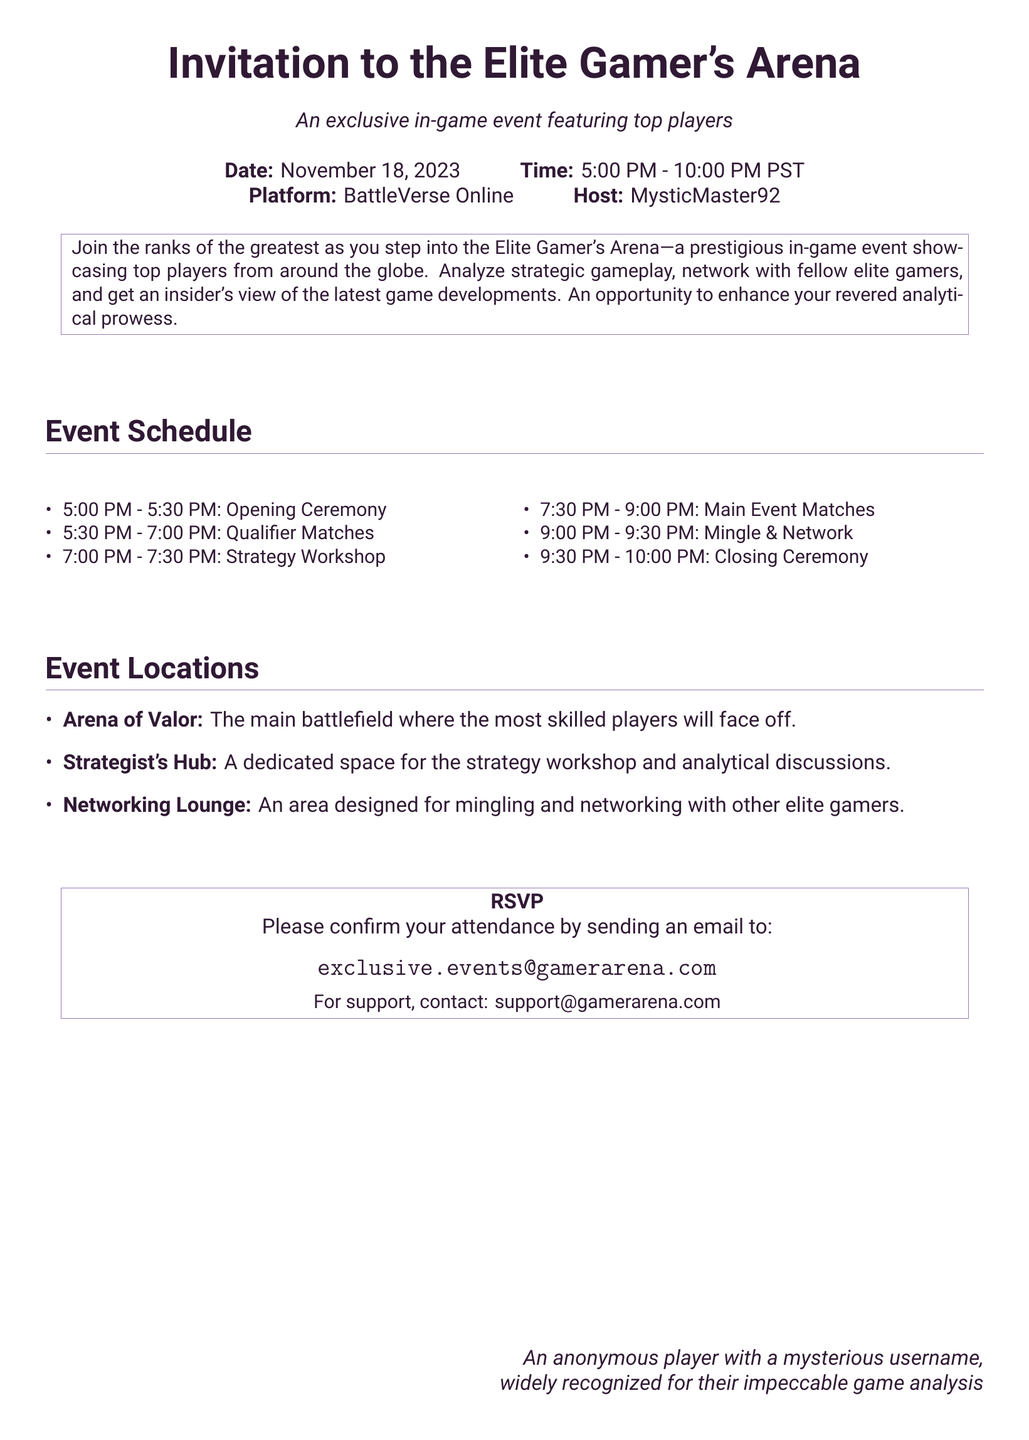What is the date of the event? The date of the event is explicitly mentioned in the document as November 18, 2023.
Answer: November 18, 2023 Who is the host of the event? The host of the event is stated in the document as MysticMaster92.
Answer: MysticMaster92 What time does the opening ceremony start? The document specifies that the opening ceremony starts at 5:00 PM.
Answer: 5:00 PM How long is the strategy workshop? The document indicates that the strategy workshop lasts 30 minutes from 7:00 PM to 7:30 PM.
Answer: 30 minutes What is the final event on the schedule? The last item listed in the event schedule is the Closing Ceremony.
Answer: Closing Ceremony Which location is dedicated for the strategy workshop? The document names the Strategist's Hub as the space for the strategy workshop.
Answer: Strategist's Hub What is the email address for RSVP? The RSVP email address provided in the document is exclusive.events@gamerarena.com.
Answer: exclusive.events@gamerarena.com How many locations are listed in the event locations section? The document lists three locations: Arena of Valor, Strategist's Hub, and Networking Lounge.
Answer: Three What activity occurs between 9:00 PM and 9:30 PM? According to the event schedule, the activity during this time is Mingle & Network.
Answer: Mingle & Network What is the starting time of the main event matches? The starting time for the main event matches as per the schedule is 7:30 PM.
Answer: 7:30 PM 